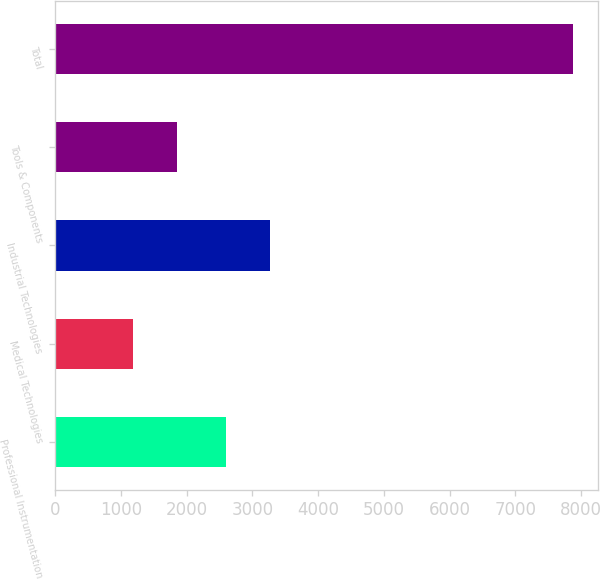Convert chart. <chart><loc_0><loc_0><loc_500><loc_500><bar_chart><fcel>Professional Instrumentation<fcel>Medical Technologies<fcel>Industrial Technologies<fcel>Tools & Components<fcel>Total<nl><fcel>2600.6<fcel>1181.5<fcel>3269.6<fcel>1850.5<fcel>7871.5<nl></chart> 